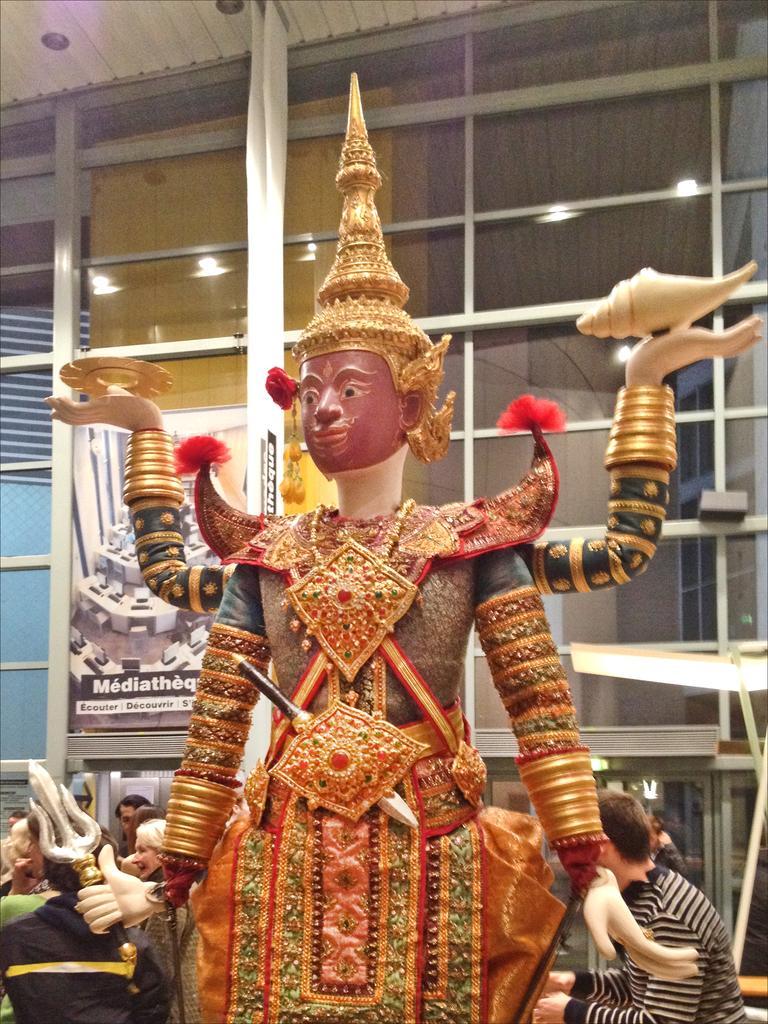Can you describe this image briefly? This is the picture of a room. In the foreground there is an idol. At the back there are group of people sitting. There is a hoarding on the wall and there are lights. 